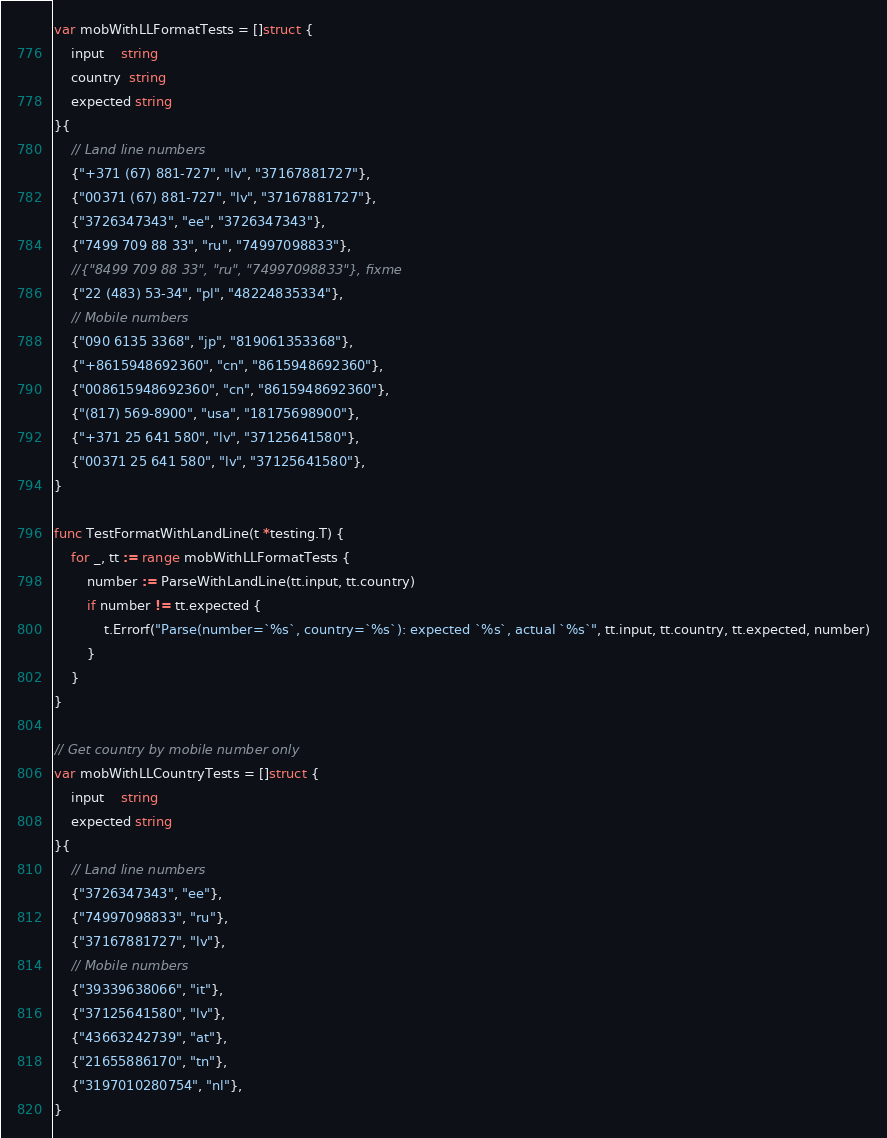<code> <loc_0><loc_0><loc_500><loc_500><_Go_>var mobWithLLFormatTests = []struct {
	input    string
	country  string
	expected string
}{
	// Land line numbers
	{"+371 (67) 881-727", "lv", "37167881727"},
	{"00371 (67) 881-727", "lv", "37167881727"},
	{"3726347343", "ee", "3726347343"},
	{"7499 709 88 33", "ru", "74997098833"},
	//{"8499 709 88 33", "ru", "74997098833"}, fixme
	{"22 (483) 53-34", "pl", "48224835334"},
	// Mobile numbers
	{"090 6135 3368", "jp", "819061353368"},
	{"+8615948692360", "cn", "8615948692360"},
	{"008615948692360", "cn", "8615948692360"},
	{"(817) 569-8900", "usa", "18175698900"},
	{"+371 25 641 580", "lv", "37125641580"},
	{"00371 25 641 580", "lv", "37125641580"},
}

func TestFormatWithLandLine(t *testing.T) {
	for _, tt := range mobWithLLFormatTests {
		number := ParseWithLandLine(tt.input, tt.country)
		if number != tt.expected {
			t.Errorf("Parse(number=`%s`, country=`%s`): expected `%s`, actual `%s`", tt.input, tt.country, tt.expected, number)
		}
	}
}

// Get country by mobile number only
var mobWithLLCountryTests = []struct {
	input    string
	expected string
}{
	// Land line numbers
	{"3726347343", "ee"},
	{"74997098833", "ru"},
	{"37167881727", "lv"},
	// Mobile numbers
	{"39339638066", "it"},
	{"37125641580", "lv"},
	{"43663242739", "at"},
	{"21655886170", "tn"},
	{"3197010280754", "nl"},
}
</code> 